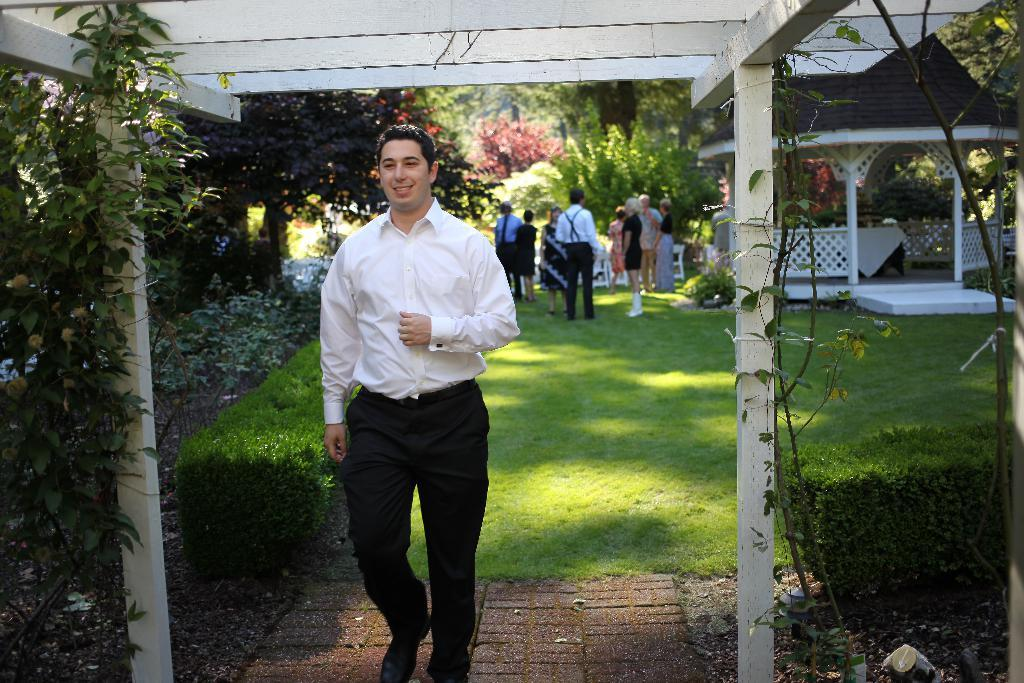What is the person in the image wearing? The person in the image is wearing a white and black dress. What can be seen in the background of the image? There are trees, plants, fencing under a roof, and other unspecified objects in the background of the image. How does the person in the image express their pain? There is no indication of pain in the image; the person is simply wearing a white and black dress. What type of basket is visible in the image? There is no basket present in the image. 